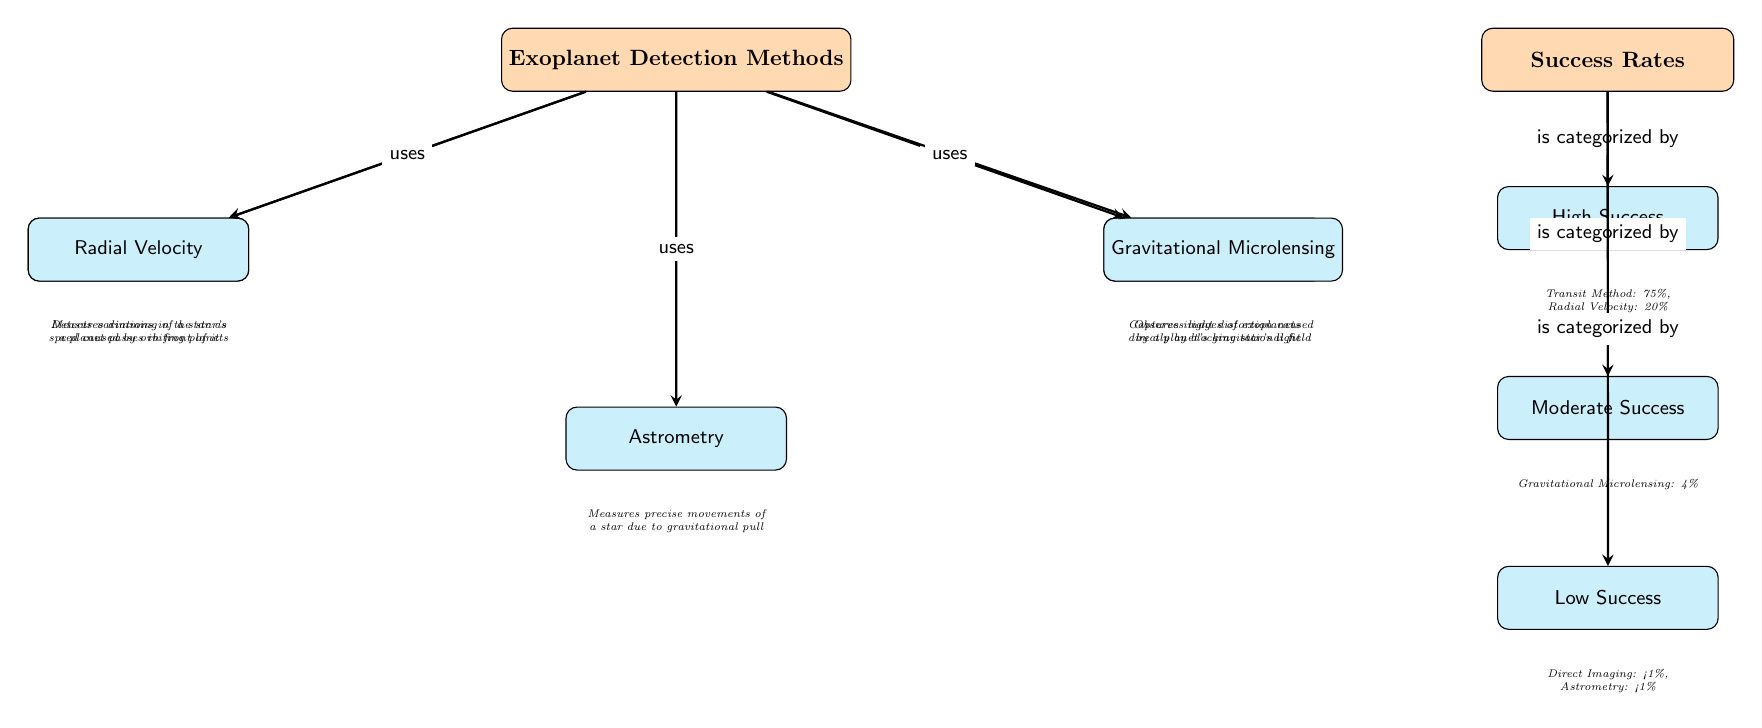What are the five exoplanet detection methods shown in the diagram? The diagram lists five methods for detecting exoplanets: Transit Method, Radial Velocity, Direct Imaging, Gravitational Microlensing, and Astrometry.
Answer: Transit Method, Radial Velocity, Direct Imaging, Gravitational Microlensing, Astrometry Which exoplanet detection method has the highest success rate? The Transit Method is indicated as having the highest success rate at 75%, which is directly noted in the diagram.
Answer: 75% What does the Radial Velocity method detect? The diagram states that the Radial Velocity method detects variations in the star's speed caused by orbiting planets. This information is included as a detail beneath the Radial Velocity node.
Answer: Variations in the star's speed How is the success rate categorized in the diagram? The success rates are categorized into High Success, Moderate Success, and Low Success, as shown by the different nodes linked from the Success Rates node.
Answer: High Success, Moderate Success, Low Success Which detection method has a success rate categorized as Low Success? The diagram specifies that both Direct Imaging and Astrometry have less than 1% success rate, categorizing them into the Low Success category.
Answer: Direct Imaging, Astrometry What is the success rate of Gravitational Microlensing? According to the diagram, the success rate of Gravitational Microlensing is indicated as 4%, which is noted in the Low Success section.
Answer: 4% How does the Transit Method function? The diagram provides the function of the Transit Method as measuring the dimming of a star when a planet passes in front of it, a detail found directly below the Transit Method node.
Answer: Measures dimming of a star What is the relationship between the detection methods and success rates in the diagram? The diagram shows that each method is connected to the corresponding success rate, indicating which methods fall under High, Moderate, and Low success categories based on their effectiveness in detecting exoplanets.
Answer: Each method uses a categorized success rate Which detection method has the lowest success rate? The diagram illustrates that both Direct Imaging and Astrometry have success rates of less than 1%, indicating they share the lowest success rate among the methods presented.
Answer: Direct Imaging, Astrometry 